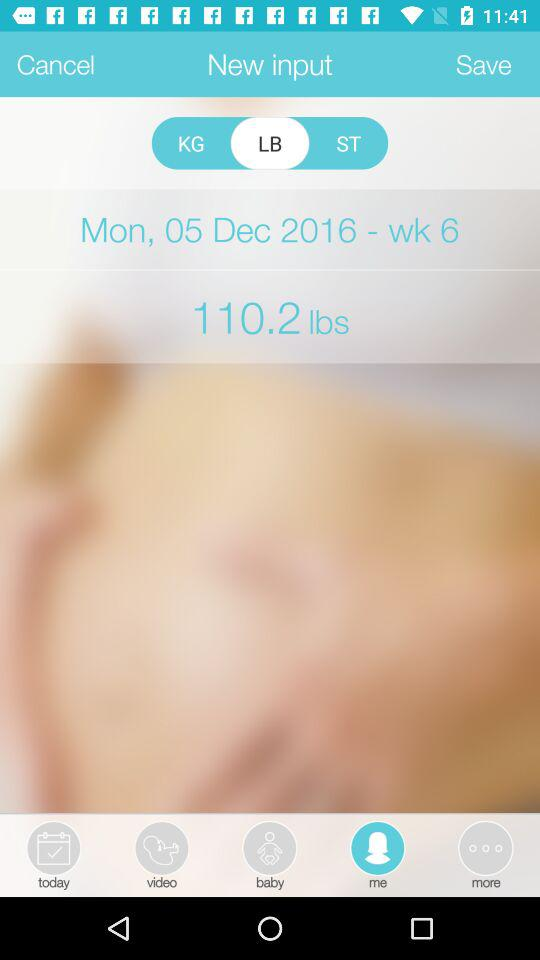What is the week number? The week number is 6. 